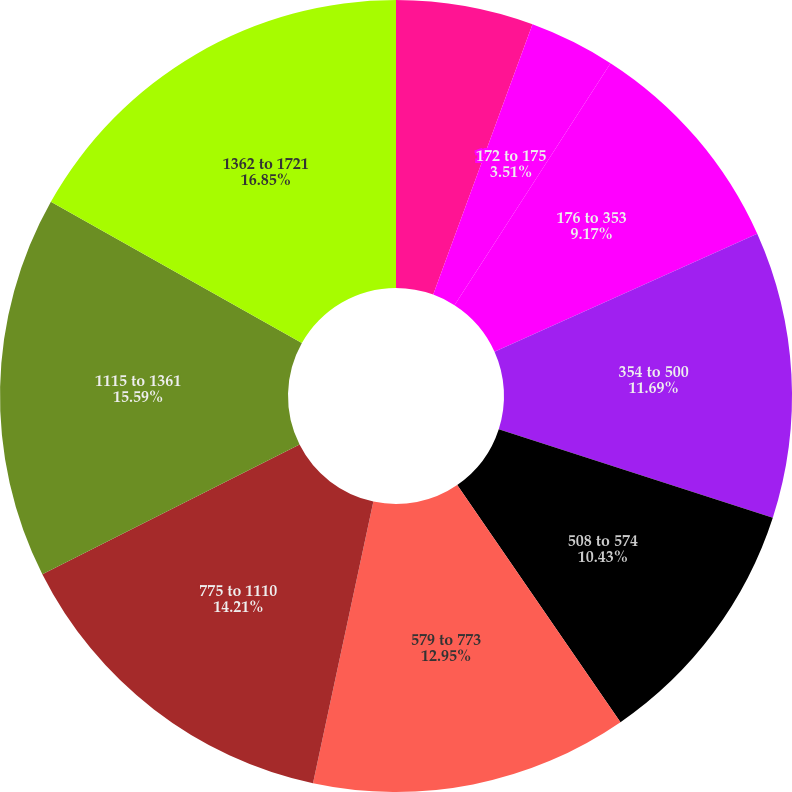Convert chart. <chart><loc_0><loc_0><loc_500><loc_500><pie_chart><fcel>100 to 108<fcel>172 to 175<fcel>176 to 353<fcel>354 to 500<fcel>508 to 574<fcel>579 to 773<fcel>775 to 1110<fcel>1115 to 1361<fcel>1362 to 1721<nl><fcel>5.6%<fcel>3.51%<fcel>9.17%<fcel>11.69%<fcel>10.43%<fcel>12.95%<fcel>14.21%<fcel>15.58%<fcel>16.84%<nl></chart> 